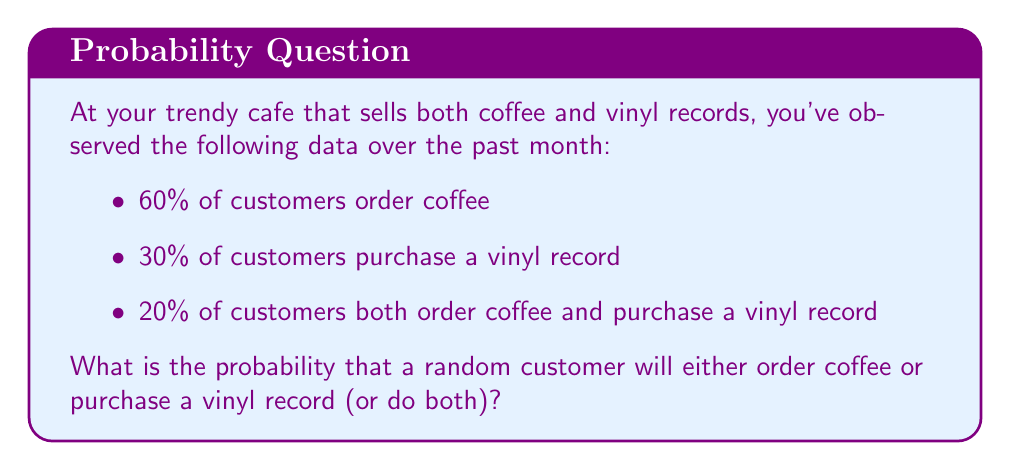Could you help me with this problem? To solve this problem, we'll use the addition rule of probability. Let's define our events:

$A$: Customer orders coffee
$B$: Customer purchases a vinyl record

We're given:
$P(A) = 0.60$
$P(B) = 0.30$
$P(A \cap B) = 0.20$

We want to find $P(A \cup B)$, which is the probability of a customer either ordering coffee or purchasing a vinyl record (or doing both).

The addition rule of probability states:

$$P(A \cup B) = P(A) + P(B) - P(A \cap B)$$

This formula accounts for the overlap between the two events, ensuring we don't double-count customers who both order coffee and purchase a vinyl record.

Substituting our known values:

$$P(A \cup B) = 0.60 + 0.30 - 0.20$$

$$P(A \cup B) = 0.70$$
Answer: The probability that a random customer will either order coffee or purchase a vinyl record (or do both) is 0.70 or 70%. 